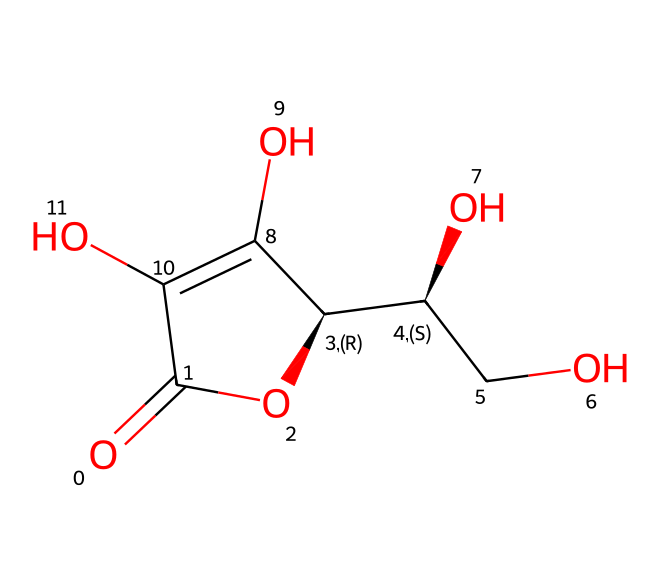What is the molecular formula of Vitamin C? From the SMILES representation, we can identify the atoms present. Counting each type of atom, we have: 6 carbon (C) atoms, 8 hydrogen (H) atoms, and 6 oxygen (O) atoms. Therefore, by combining these counts into a formula, we arrive at C6H8O6.
Answer: C6H8O6 How many hydroxyl (–OH) groups are in Vitamin C? By observing the structure, we can identify the functional groups. There are two identifiable hydroxyl (–OH) groups in the carbon chain of Vitamin C, which are typically shown in the chemical structure.
Answer: 2 Which functional group is primarily responsible for the antioxidant properties of Vitamin C? The presence of multiple hydroxyl (–OH) groups and a lactone formation in the structure is key to Vitamin C's antioxidant properties. The ability of these hydroxyl groups to donate hydrogen atoms contributes to its role as an antioxidant.
Answer: hydroxyl groups What type of stereochemistry does Vitamin C exhibit? In the chemical structure, we see chiral centers indicated by the stereocenters (C@H notation) in the SMILES. This indicates that Vitamin C exhibits chirality, meaning it has distinct optical isomers.
Answer: chirality How does the structure of Vitamin C relate to its role in immune health? The structure with both hydroxyl groups and the lactone ring allows Vitamin C to easily donate electrons in biochemical reactions, which aids in the regeneration of other antioxidants and supports immune function by maintaining healthy immune response.
Answer: electron donor What is the primary method by which Vitamin C enhances immune function? Vitamin C enhances immune function primarily by supporting the proliferation and function of immune cells, particularly lymphocytes and phagocytes, due to its role in antioxidant defense systems as indicated by its structure and biochemical activity.
Answer: antioxidant defense 